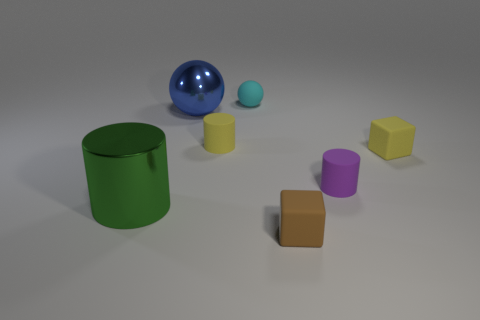What number of things are either large blue balls that are behind the purple cylinder or gray rubber balls?
Your answer should be very brief. 1. Does the big blue sphere have the same material as the cylinder on the left side of the large blue metallic ball?
Your response must be concise. Yes. Are there any purple objects that have the same material as the yellow cube?
Keep it short and to the point. Yes. What number of things are either tiny cylinders that are in front of the yellow cylinder or small rubber objects on the right side of the small cyan object?
Your answer should be very brief. 3. There is a small purple thing; is its shape the same as the yellow rubber thing that is right of the purple thing?
Your answer should be very brief. No. How many other things are the same shape as the tiny purple rubber thing?
Provide a short and direct response. 2. How many objects are either big green cylinders or tiny green cylinders?
Your answer should be compact. 1. There is a yellow object left of the matte thing that is in front of the purple rubber thing; what shape is it?
Provide a succinct answer. Cylinder. Are there fewer green metallic cylinders than brown shiny spheres?
Keep it short and to the point. No. There is a cylinder that is both to the left of the tiny purple matte cylinder and in front of the yellow block; how big is it?
Your answer should be compact. Large. 